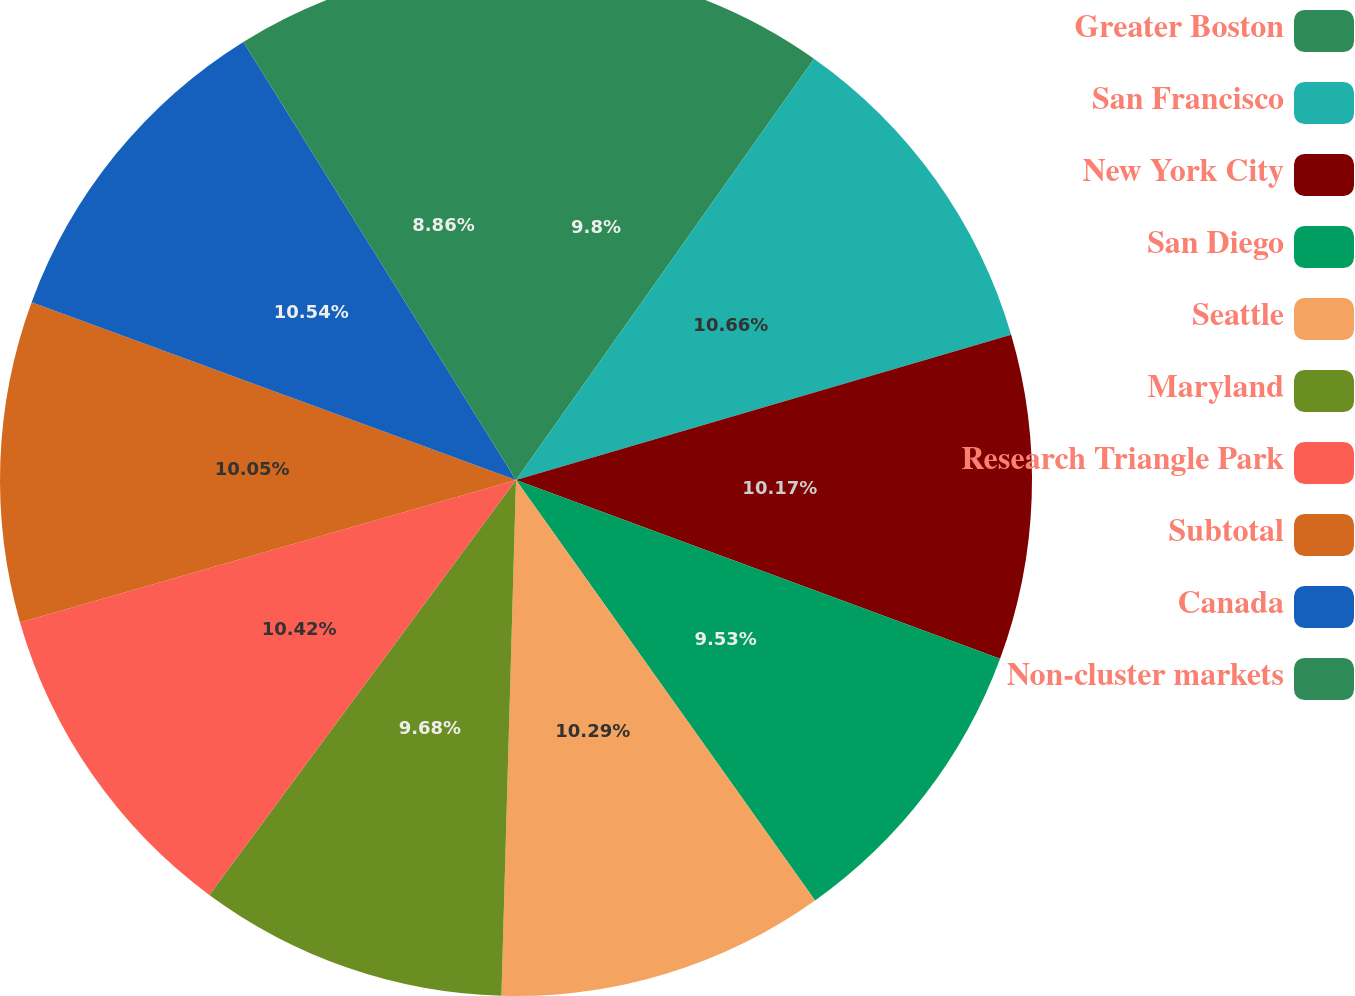<chart> <loc_0><loc_0><loc_500><loc_500><pie_chart><fcel>Greater Boston<fcel>San Francisco<fcel>New York City<fcel>San Diego<fcel>Seattle<fcel>Maryland<fcel>Research Triangle Park<fcel>Subtotal<fcel>Canada<fcel>Non-cluster markets<nl><fcel>9.8%<fcel>10.66%<fcel>10.17%<fcel>9.53%<fcel>10.29%<fcel>9.68%<fcel>10.42%<fcel>10.05%<fcel>10.54%<fcel>8.86%<nl></chart> 